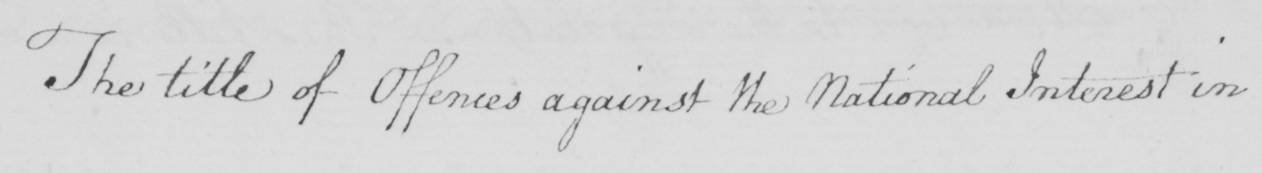Please provide the text content of this handwritten line. The title of Offences against the National Interest in 